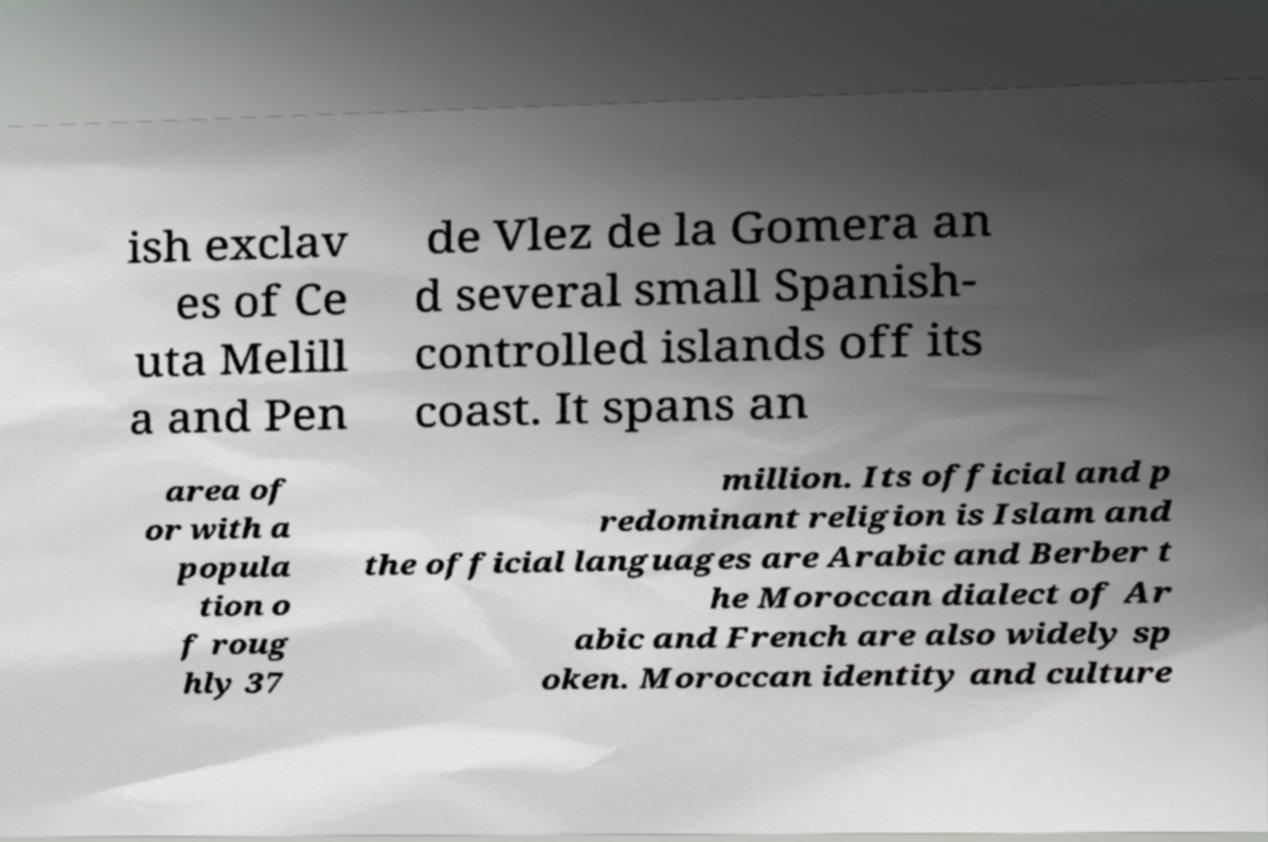Could you assist in decoding the text presented in this image and type it out clearly? ish exclav es of Ce uta Melill a and Pen de Vlez de la Gomera an d several small Spanish- controlled islands off its coast. It spans an area of or with a popula tion o f roug hly 37 million. Its official and p redominant religion is Islam and the official languages are Arabic and Berber t he Moroccan dialect of Ar abic and French are also widely sp oken. Moroccan identity and culture 